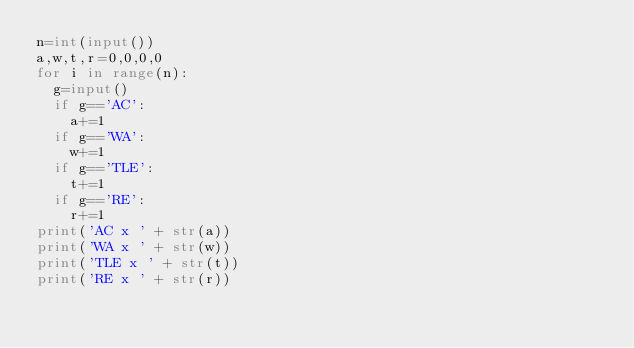<code> <loc_0><loc_0><loc_500><loc_500><_Python_>n=int(input())
a,w,t,r=0,0,0,0
for i in range(n):
  g=input()
  if g=='AC':
    a+=1
  if g=='WA':
    w+=1
  if g=='TLE':
    t+=1
  if g=='RE':
    r+=1
print('AC x ' + str(a))
print('WA x ' + str(w))
print('TLE x ' + str(t))
print('RE x ' + str(r))</code> 